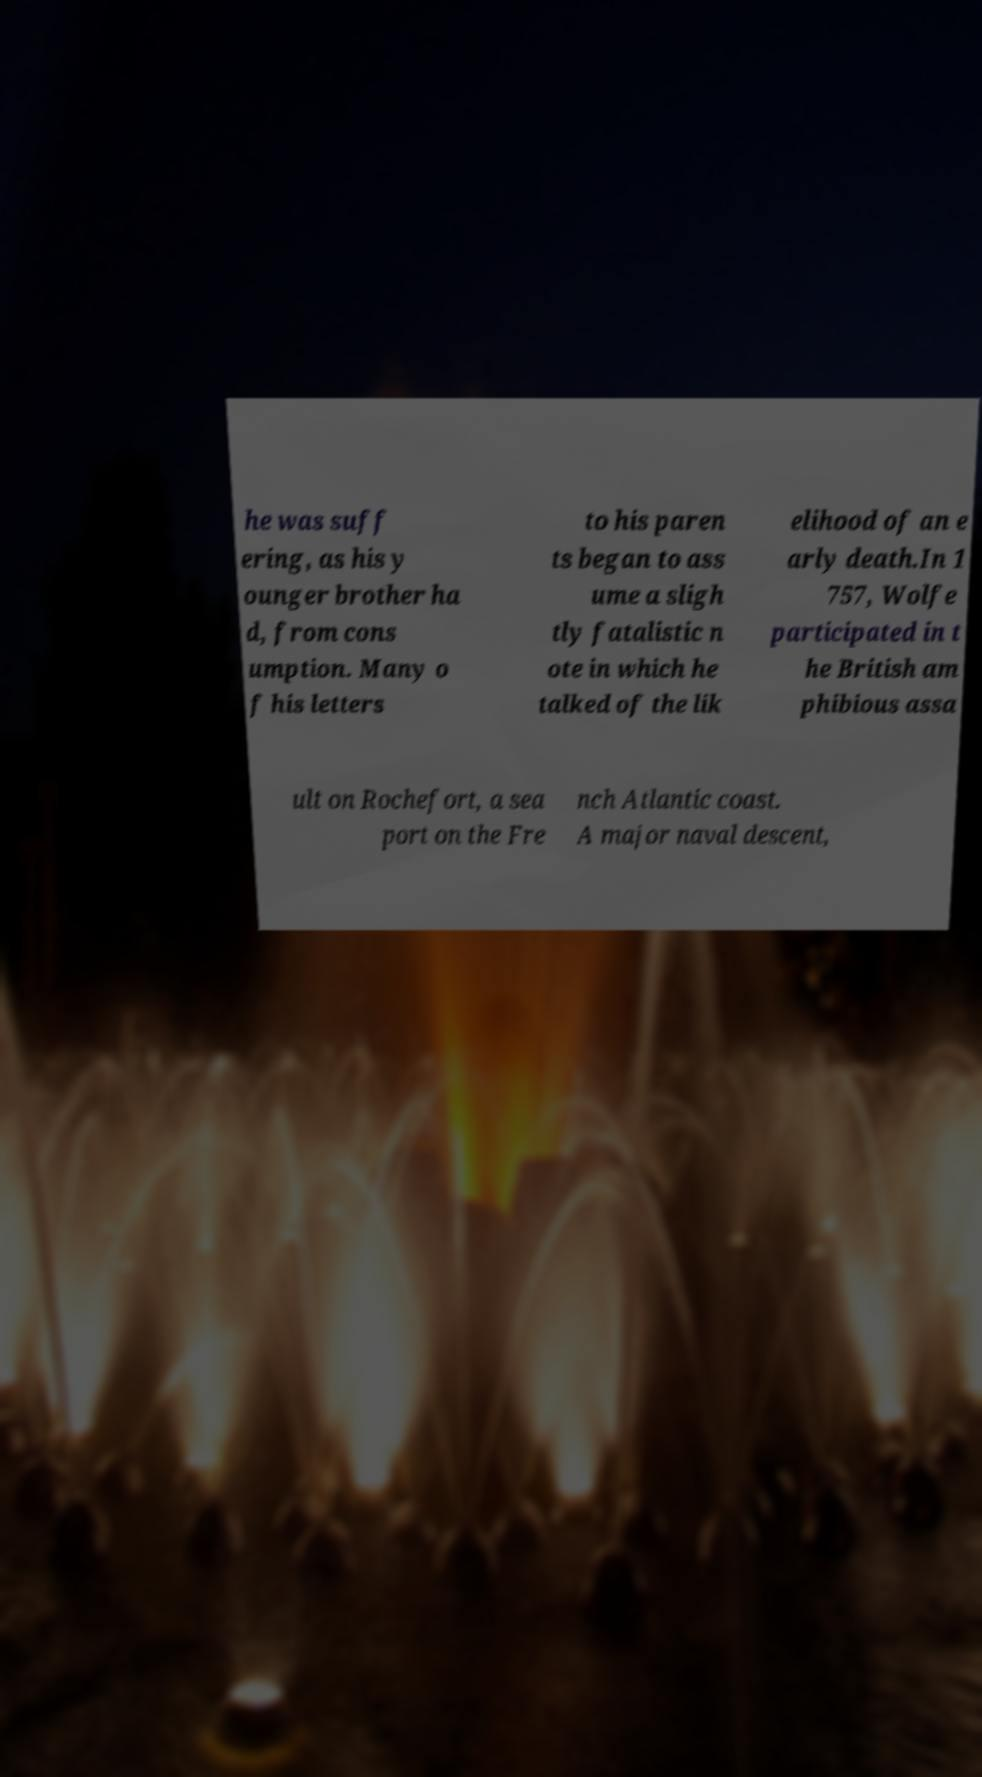Can you read and provide the text displayed in the image?This photo seems to have some interesting text. Can you extract and type it out for me? he was suff ering, as his y ounger brother ha d, from cons umption. Many o f his letters to his paren ts began to ass ume a sligh tly fatalistic n ote in which he talked of the lik elihood of an e arly death.In 1 757, Wolfe participated in t he British am phibious assa ult on Rochefort, a sea port on the Fre nch Atlantic coast. A major naval descent, 